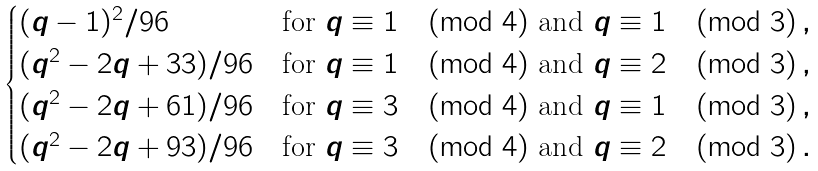Convert formula to latex. <formula><loc_0><loc_0><loc_500><loc_500>\begin{cases} ( q - 1 ) ^ { 2 } / 9 6 & \text {for $q\equiv 1\pmod{4}$ and $q\equiv 1\pmod{3}$} \, , \\ ( q ^ { 2 } - 2 q + 3 3 ) / 9 6 & \text {for $q\equiv 1\pmod{4}$ and $q\equiv 2\pmod{3}$} \, , \\ ( q ^ { 2 } - 2 q + 6 1 ) / 9 6 & \text {for $q\equiv 3\pmod{4}$ and $q\equiv 1\pmod{3}$} \, , \\ ( q ^ { 2 } - 2 q + 9 3 ) / 9 6 & \text {for $q\equiv 3\pmod{4}$ and $q\equiv 2\pmod{3}$} \, . \end{cases}</formula> 